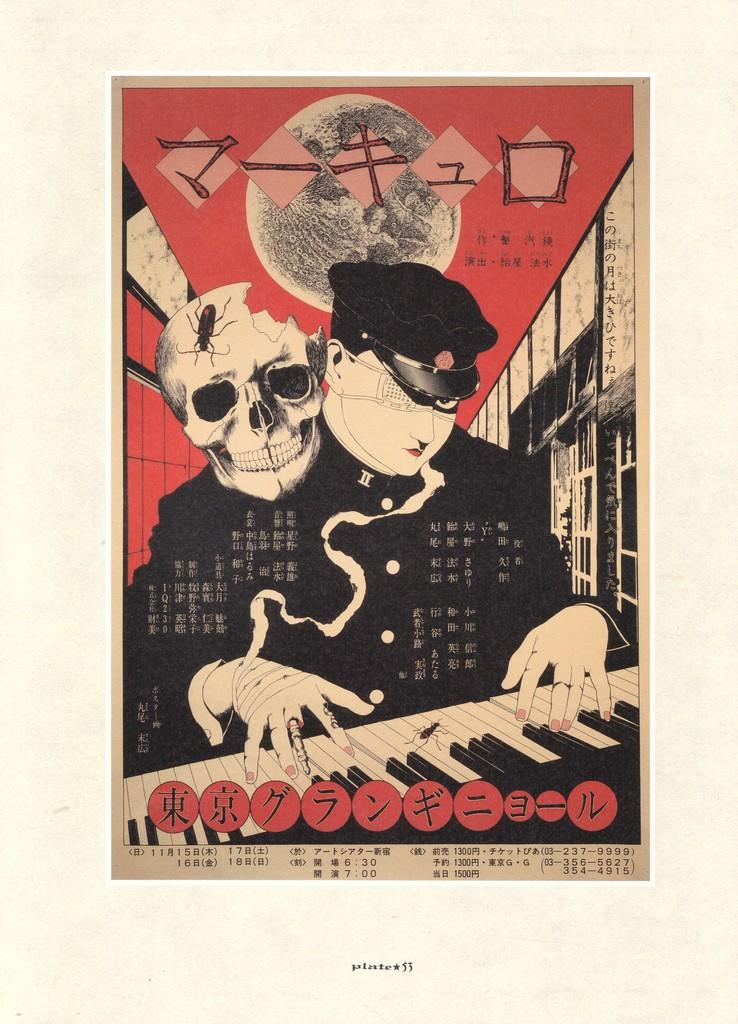What is depicted on the poster in the image? The poster features a person, a skull, and a keyboard. What is the background color of the image? The background color of the image is cream. What type of celery can be seen growing in the background of the image? There is no celery present in the image; the background color is cream. How many mountains are visible in the image? There are no mountains visible in the image; the focus is on the poster and its elements. 